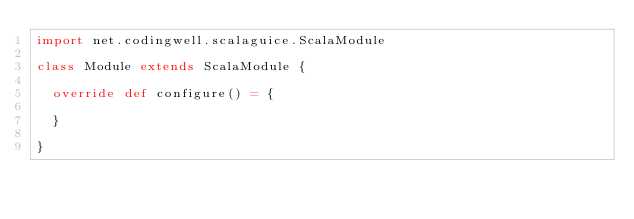Convert code to text. <code><loc_0><loc_0><loc_500><loc_500><_Scala_>import net.codingwell.scalaguice.ScalaModule

class Module extends ScalaModule {

  override def configure() = {

  }

}
</code> 